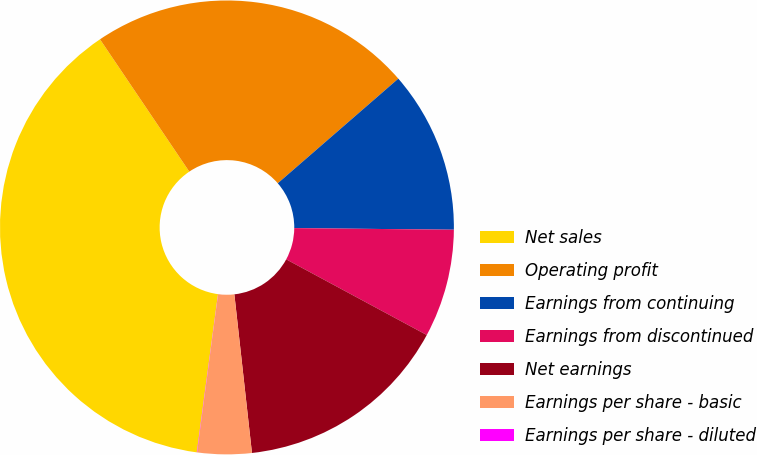Convert chart. <chart><loc_0><loc_0><loc_500><loc_500><pie_chart><fcel>Net sales<fcel>Operating profit<fcel>Earnings from continuing<fcel>Earnings from discontinued<fcel>Net earnings<fcel>Earnings per share - basic<fcel>Earnings per share - diluted<nl><fcel>38.43%<fcel>23.07%<fcel>11.54%<fcel>7.7%<fcel>15.38%<fcel>3.86%<fcel>0.02%<nl></chart> 